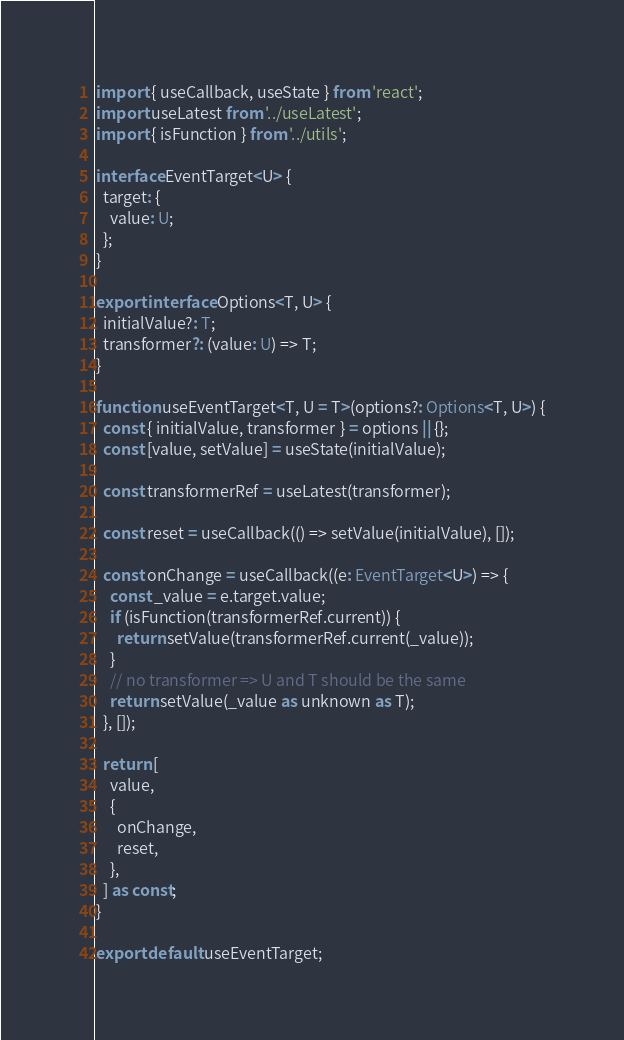Convert code to text. <code><loc_0><loc_0><loc_500><loc_500><_TypeScript_>import { useCallback, useState } from 'react';
import useLatest from '../useLatest';
import { isFunction } from '../utils';

interface EventTarget<U> {
  target: {
    value: U;
  };
}

export interface Options<T, U> {
  initialValue?: T;
  transformer?: (value: U) => T;
}

function useEventTarget<T, U = T>(options?: Options<T, U>) {
  const { initialValue, transformer } = options || {};
  const [value, setValue] = useState(initialValue);

  const transformerRef = useLatest(transformer);

  const reset = useCallback(() => setValue(initialValue), []);

  const onChange = useCallback((e: EventTarget<U>) => {
    const _value = e.target.value;
    if (isFunction(transformerRef.current)) {
      return setValue(transformerRef.current(_value));
    }
    // no transformer => U and T should be the same
    return setValue(_value as unknown as T);
  }, []);

  return [
    value,
    {
      onChange,
      reset,
    },
  ] as const;
}

export default useEventTarget;
</code> 